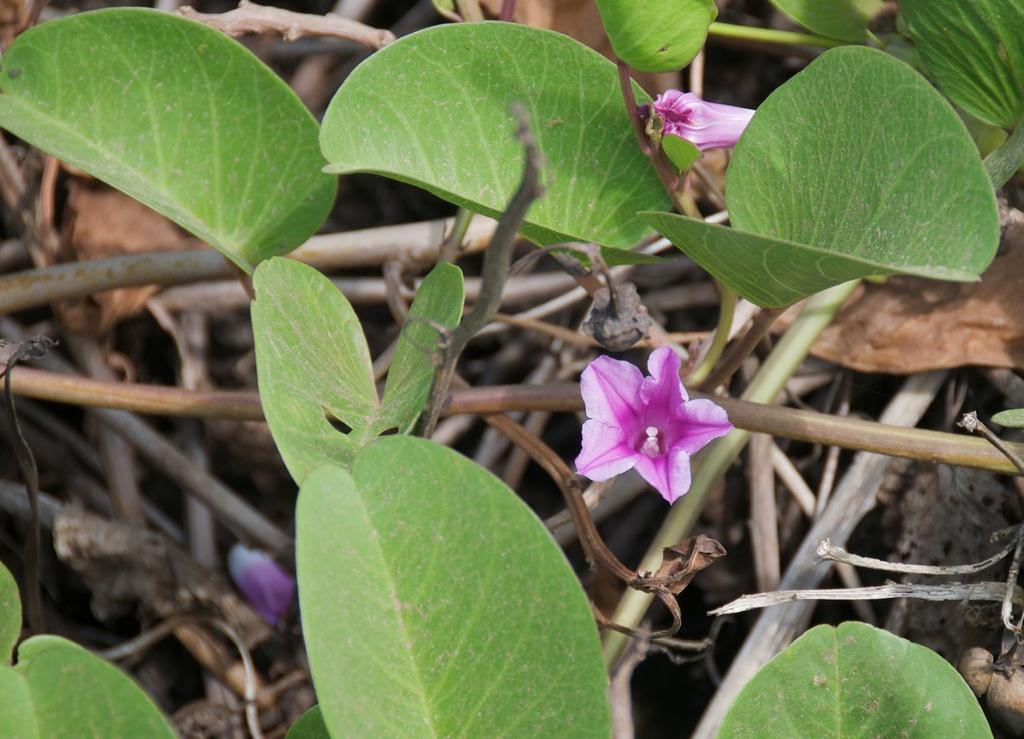Describe this image in one or two sentences. In this image we can see pink color flowers, leaves and stems. 